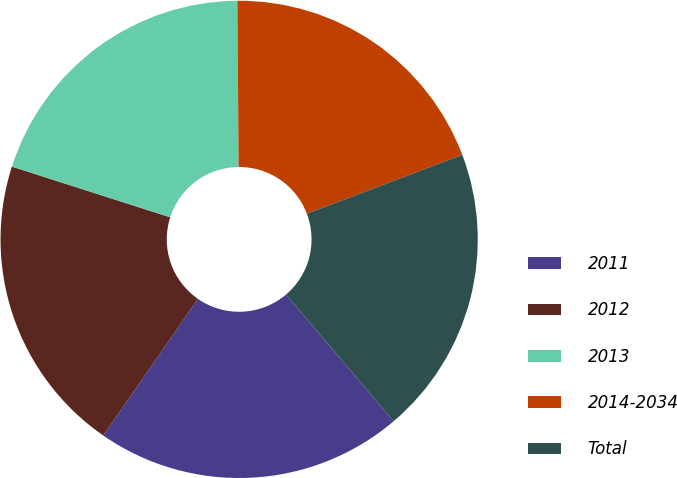Convert chart to OTSL. <chart><loc_0><loc_0><loc_500><loc_500><pie_chart><fcel>2011<fcel>2012<fcel>2013<fcel>2014-2034<fcel>Total<nl><fcel>20.85%<fcel>20.29%<fcel>19.95%<fcel>19.36%<fcel>19.56%<nl></chart> 